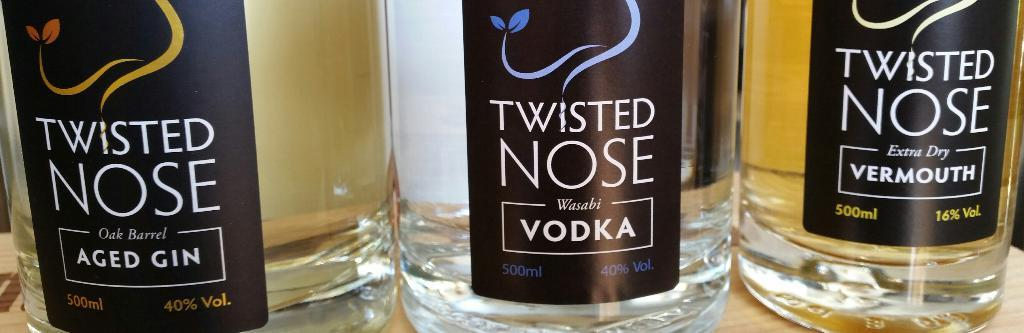<image>
Describe the image concisely. Three bottles of Twisted Nose alcohol are lined up next to each other. 